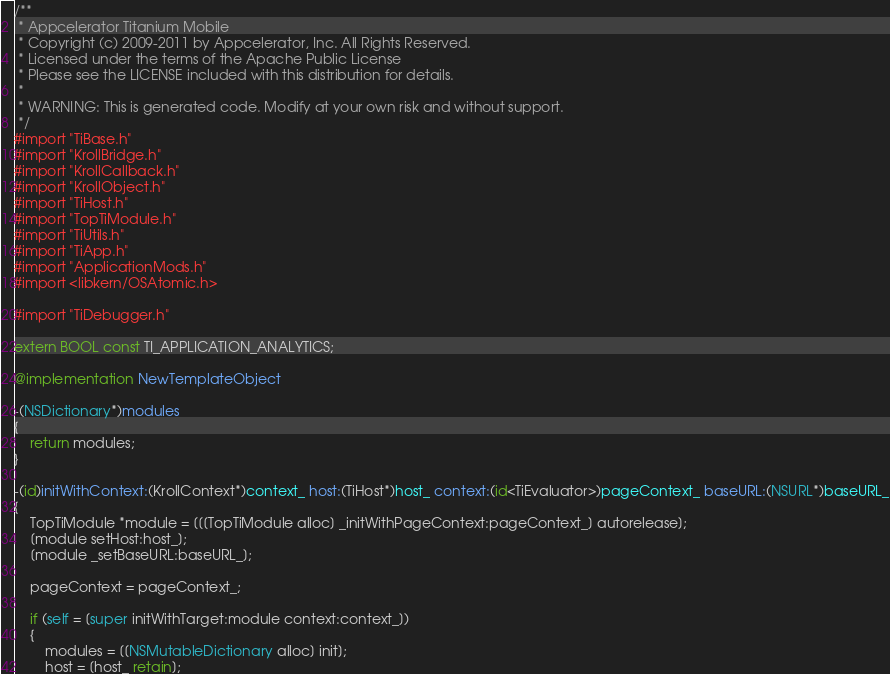Convert code to text. <code><loc_0><loc_0><loc_500><loc_500><_ObjectiveC_>/**
 * Appcelerator Titanium Mobile
 * Copyright (c) 2009-2011 by Appcelerator, Inc. All Rights Reserved.
 * Licensed under the terms of the Apache Public License
 * Please see the LICENSE included with this distribution for details.
 * 
 * WARNING: This is generated code. Modify at your own risk and without support.
 */
#import "TiBase.h"
#import "KrollBridge.h"
#import "KrollCallback.h"
#import "KrollObject.h"
#import "TiHost.h"
#import "TopTiModule.h"
#import "TiUtils.h"
#import "TiApp.h"
#import "ApplicationMods.h"
#import <libkern/OSAtomic.h>

#import "TiDebugger.h"

extern BOOL const TI_APPLICATION_ANALYTICS;

@implementation NewTemplateObject

-(NSDictionary*)modules
{
	return modules;
}

-(id)initWithContext:(KrollContext*)context_ host:(TiHost*)host_ context:(id<TiEvaluator>)pageContext_ baseURL:(NSURL*)baseURL_
{
	TopTiModule *module = [[[TopTiModule alloc] _initWithPageContext:pageContext_] autorelease];
	[module setHost:host_];
	[module _setBaseURL:baseURL_];
	
	pageContext = pageContext_;
	
	if (self = [super initWithTarget:module context:context_])
	{
		modules = [[NSMutableDictionary alloc] init];
		host = [host_ retain];</code> 